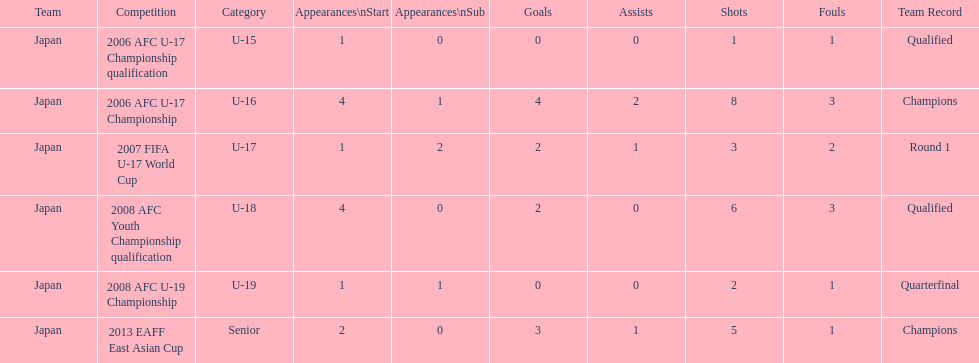In which major competitions did yoichiro kakitani have at least 3 starts? 2006 AFC U-17 Championship, 2008 AFC Youth Championship qualification. 